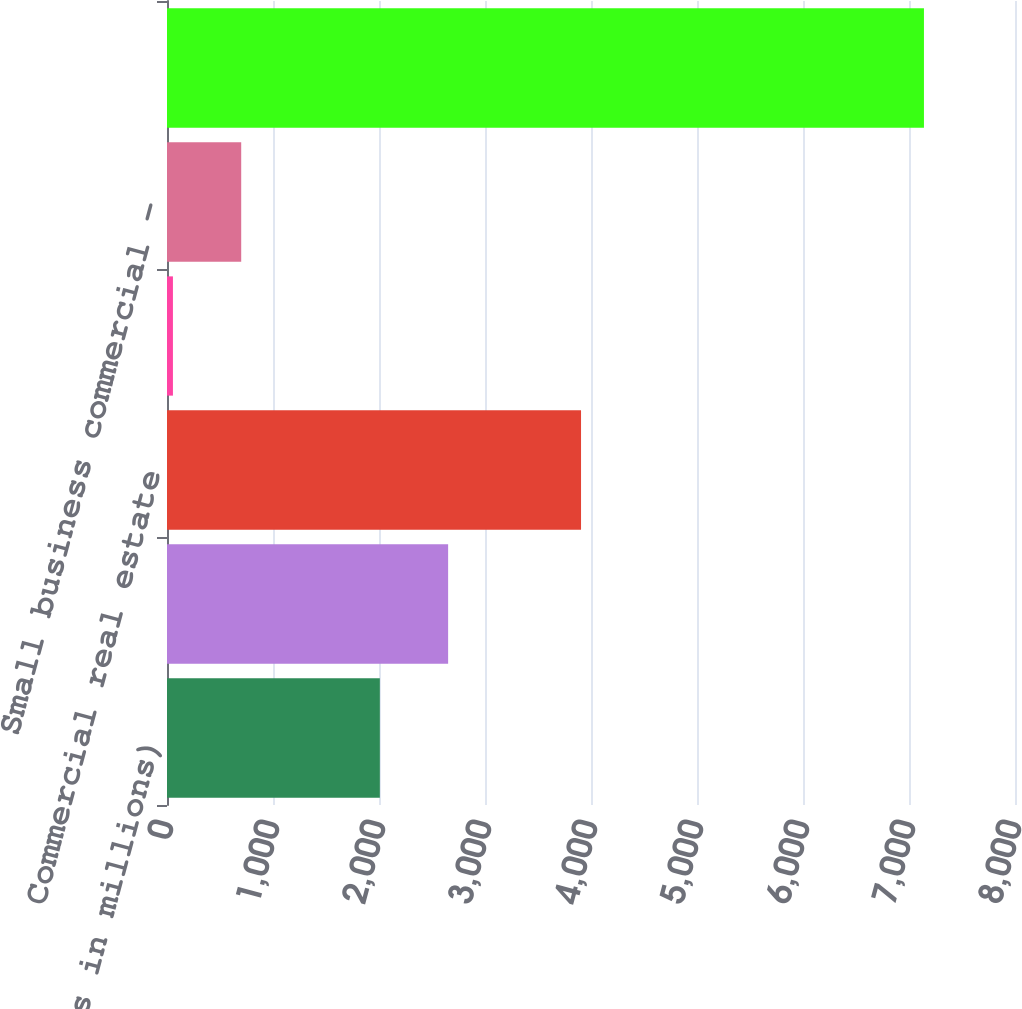Convert chart. <chart><loc_0><loc_0><loc_500><loc_500><bar_chart><fcel>(Dollars in millions)<fcel>Commercial - domestic (4)<fcel>Commercial real estate<fcel>Commercial lease financing<fcel>Small business commercial -<fcel>Total commercial loans and<nl><fcel>2008<fcel>2652.1<fcel>3906<fcel>56<fcel>700.1<fcel>7141.1<nl></chart> 